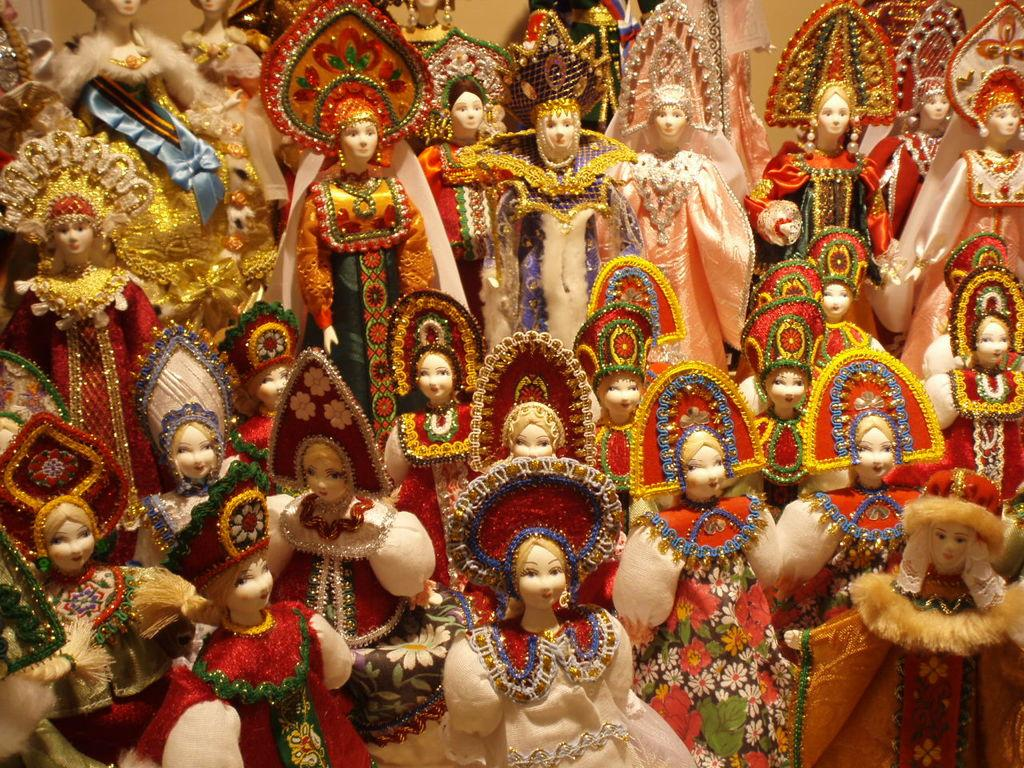What is the main subject in the center of the image? There are dolls in the center of the image. What can be observed about the dolls' appearance? The dolls are wearing different colorful costumes. What can be seen in the background of the image? There is a wall in the background of the image. What verse can be heard being recited by the dolls in the image? There is no indication in the image that the dolls are reciting a verse, so it cannot be determined from the picture. 